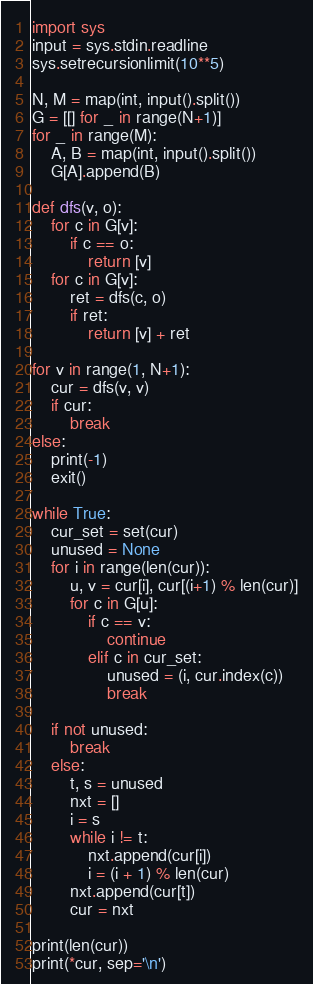Convert code to text. <code><loc_0><loc_0><loc_500><loc_500><_Python_>import sys
input = sys.stdin.readline
sys.setrecursionlimit(10**5)

N, M = map(int, input().split())
G = [[] for _ in range(N+1)]
for _ in range(M):
    A, B = map(int, input().split())
    G[A].append(B)

def dfs(v, o):
    for c in G[v]:
        if c == o:
            return [v]
    for c in G[v]:
        ret = dfs(c, o)
        if ret:
            return [v] + ret

for v in range(1, N+1):
    cur = dfs(v, v)
    if cur:
        break
else:
    print(-1)
    exit()

while True:
    cur_set = set(cur)
    unused = None
    for i in range(len(cur)):
        u, v = cur[i], cur[(i+1) % len(cur)]
        for c in G[u]:
            if c == v:
                continue
            elif c in cur_set:
                unused = (i, cur.index(c))
                break

    if not unused:
        break
    else:
        t, s = unused
        nxt = []
        i = s
        while i != t:
            nxt.append(cur[i])
            i = (i + 1) % len(cur)
        nxt.append(cur[t])
        cur = nxt

print(len(cur))
print(*cur, sep='\n')</code> 